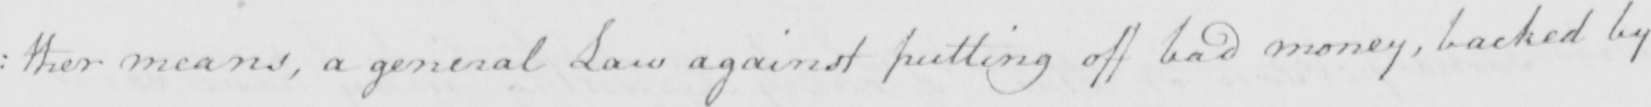Can you tell me what this handwritten text says? : ther means , a general Law against putting off bad money , backed by 